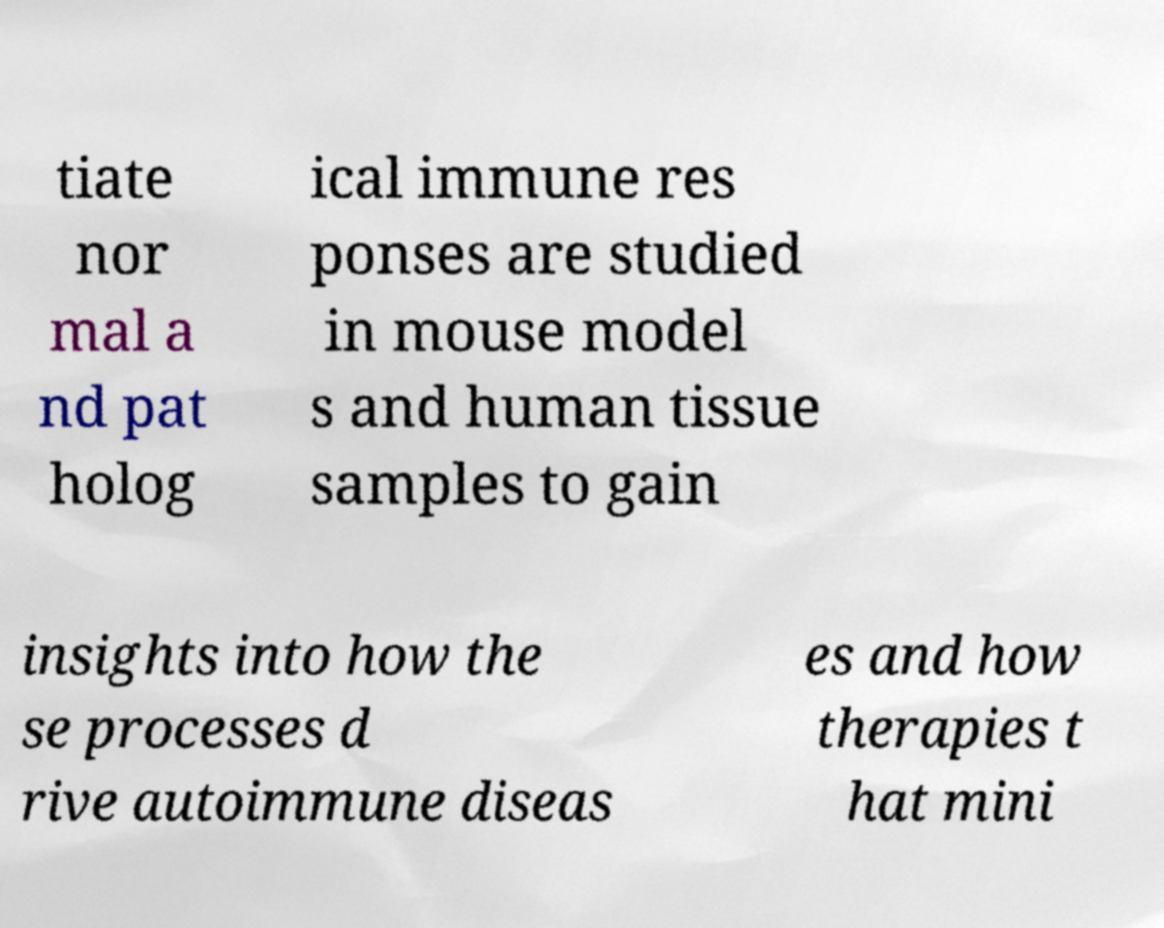Please read and relay the text visible in this image. What does it say? tiate nor mal a nd pat holog ical immune res ponses are studied in mouse model s and human tissue samples to gain insights into how the se processes d rive autoimmune diseas es and how therapies t hat mini 